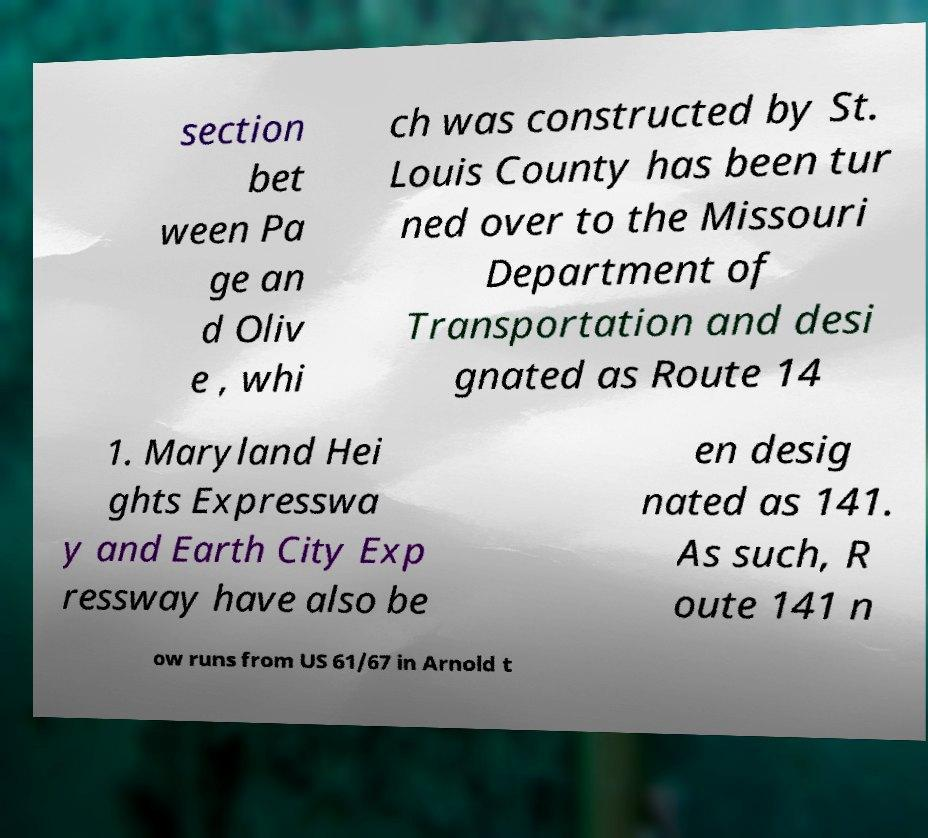There's text embedded in this image that I need extracted. Can you transcribe it verbatim? section bet ween Pa ge an d Oliv e , whi ch was constructed by St. Louis County has been tur ned over to the Missouri Department of Transportation and desi gnated as Route 14 1. Maryland Hei ghts Expresswa y and Earth City Exp ressway have also be en desig nated as 141. As such, R oute 141 n ow runs from US 61/67 in Arnold t 